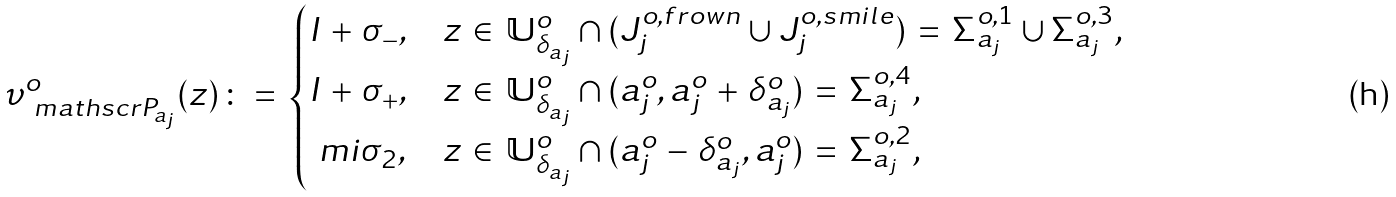<formula> <loc_0><loc_0><loc_500><loc_500>\upsilon _ { \ m a t h s c r { P } _ { a _ { j } } } ^ { o } ( z ) \, \colon = \, \begin{cases} I \, + \, \sigma _ { - } , & \text {$z \, \in \, \mathbb{U}_{\delta_{a_{j}} }^{o} \cap (J_{j}^{o,frown} \cup J_{j}^{o,smile}) \, = \, \Sigma^{ o,1}_{a_{j}} \cup \Sigma^{o,3}_{a_{j}}$,} \\ I \, + \, \sigma _ { + } , & \text {$z \, \in \, \mathbb{U}_{\delta_{a_{j}} }^{o} \cap (a_{j}^{o},a_{j}^{o} \, + \, \delta_{a_{j}}^{o}) \, = \, \Sigma^{o, 4}_{a_{j}}$,} \\ \ m i \sigma _ { 2 } , & \text {$z \, \in \, \mathbb{U}_{\delta_{a_{j}}}^{o} \cap (a_{ j}^{o} \, - \, \delta_{a_{j}}^{o},a_{j}^{o}) \, = \, \Sigma^{o,2}_{a_{j}}$,} \end{cases}</formula> 